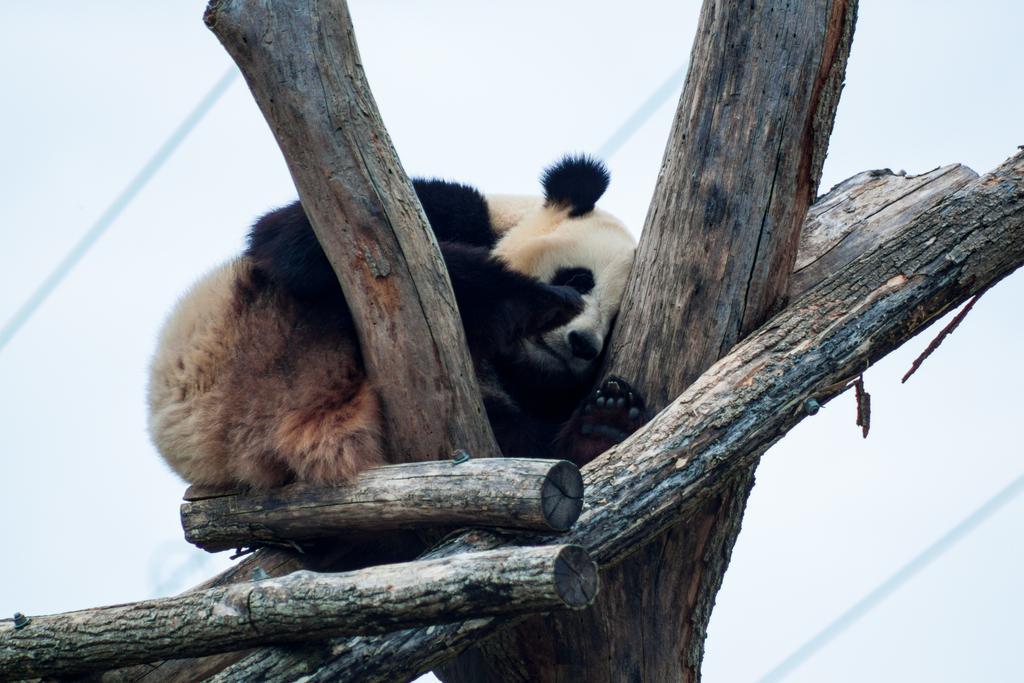Can you describe this image briefly? In this picture we observe a panda sitting on a tree with logs of wood beside it. 